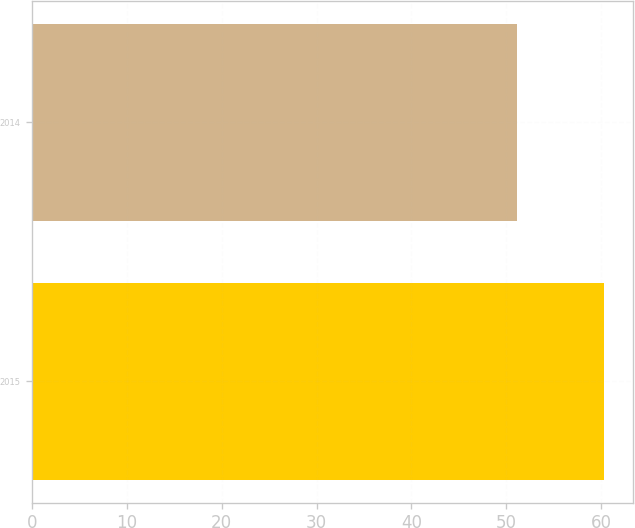Convert chart to OTSL. <chart><loc_0><loc_0><loc_500><loc_500><bar_chart><fcel>2015<fcel>2014<nl><fcel>60.3<fcel>51.12<nl></chart> 